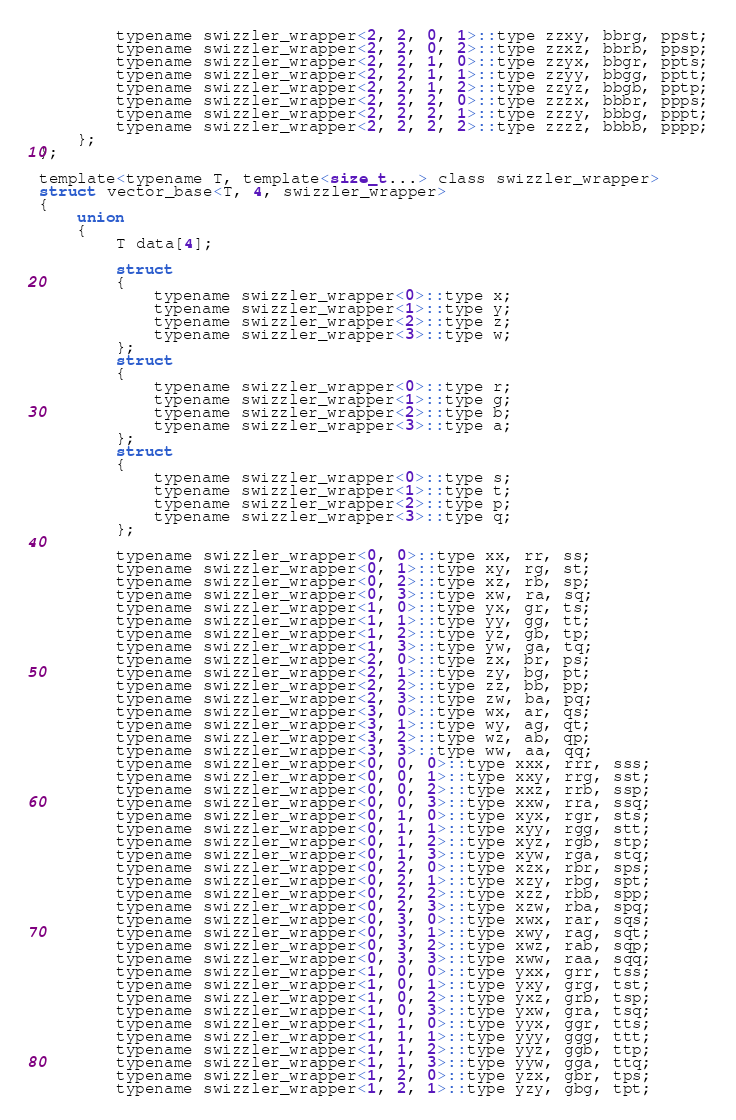Convert code to text. <code><loc_0><loc_0><loc_500><loc_500><_C_>		typename swizzler_wrapper<2, 2, 0, 1>::type zzxy, bbrg, ppst;
		typename swizzler_wrapper<2, 2, 0, 2>::type zzxz, bbrb, ppsp;
		typename swizzler_wrapper<2, 2, 1, 0>::type zzyx, bbgr, ppts;
		typename swizzler_wrapper<2, 2, 1, 1>::type zzyy, bbgg, pptt;
		typename swizzler_wrapper<2, 2, 1, 2>::type zzyz, bbgb, pptp;
		typename swizzler_wrapper<2, 2, 2, 0>::type zzzx, bbbr, ppps;
		typename swizzler_wrapper<2, 2, 2, 1>::type zzzy, bbbg, pppt;
		typename swizzler_wrapper<2, 2, 2, 2>::type zzzz, bbbb, pppp;
	};
};

template<typename T, template<size_t...> class swizzler_wrapper>
struct vector_base<T, 4, swizzler_wrapper>
{
	union
	{
		T data[4];

		struct
		{
			typename swizzler_wrapper<0>::type x;
			typename swizzler_wrapper<1>::type y;
			typename swizzler_wrapper<2>::type z;
			typename swizzler_wrapper<3>::type w;
		};
		struct
		{
			typename swizzler_wrapper<0>::type r;
			typename swizzler_wrapper<1>::type g;
			typename swizzler_wrapper<2>::type b;
			typename swizzler_wrapper<3>::type a;
		};
		struct
		{
			typename swizzler_wrapper<0>::type s;
			typename swizzler_wrapper<1>::type t;
			typename swizzler_wrapper<2>::type p;
			typename swizzler_wrapper<3>::type q;
		};

		typename swizzler_wrapper<0, 0>::type xx, rr, ss;
		typename swizzler_wrapper<0, 1>::type xy, rg, st;
		typename swizzler_wrapper<0, 2>::type xz, rb, sp;
		typename swizzler_wrapper<0, 3>::type xw, ra, sq;
		typename swizzler_wrapper<1, 0>::type yx, gr, ts;
		typename swizzler_wrapper<1, 1>::type yy, gg, tt;
		typename swizzler_wrapper<1, 2>::type yz, gb, tp;
		typename swizzler_wrapper<1, 3>::type yw, ga, tq;
		typename swizzler_wrapper<2, 0>::type zx, br, ps;
		typename swizzler_wrapper<2, 1>::type zy, bg, pt;
		typename swizzler_wrapper<2, 2>::type zz, bb, pp;
		typename swizzler_wrapper<2, 3>::type zw, ba, pq;
		typename swizzler_wrapper<3, 0>::type wx, ar, qs;
		typename swizzler_wrapper<3, 1>::type wy, ag, qt;
		typename swizzler_wrapper<3, 2>::type wz, ab, qp;
		typename swizzler_wrapper<3, 3>::type ww, aa, qq;
		typename swizzler_wrapper<0, 0, 0>::type xxx, rrr, sss;
		typename swizzler_wrapper<0, 0, 1>::type xxy, rrg, sst;
		typename swizzler_wrapper<0, 0, 2>::type xxz, rrb, ssp;
		typename swizzler_wrapper<0, 0, 3>::type xxw, rra, ssq;
		typename swizzler_wrapper<0, 1, 0>::type xyx, rgr, sts;
		typename swizzler_wrapper<0, 1, 1>::type xyy, rgg, stt;
		typename swizzler_wrapper<0, 1, 2>::type xyz, rgb, stp;
		typename swizzler_wrapper<0, 1, 3>::type xyw, rga, stq;
		typename swizzler_wrapper<0, 2, 0>::type xzx, rbr, sps;
		typename swizzler_wrapper<0, 2, 1>::type xzy, rbg, spt;
		typename swizzler_wrapper<0, 2, 2>::type xzz, rbb, spp;
		typename swizzler_wrapper<0, 2, 3>::type xzw, rba, spq;
		typename swizzler_wrapper<0, 3, 0>::type xwx, rar, sqs;
		typename swizzler_wrapper<0, 3, 1>::type xwy, rag, sqt;
		typename swizzler_wrapper<0, 3, 2>::type xwz, rab, sqp;
		typename swizzler_wrapper<0, 3, 3>::type xww, raa, sqq;
		typename swizzler_wrapper<1, 0, 0>::type yxx, grr, tss;
		typename swizzler_wrapper<1, 0, 1>::type yxy, grg, tst;
		typename swizzler_wrapper<1, 0, 2>::type yxz, grb, tsp;
		typename swizzler_wrapper<1, 0, 3>::type yxw, gra, tsq;
		typename swizzler_wrapper<1, 1, 0>::type yyx, ggr, tts;
		typename swizzler_wrapper<1, 1, 1>::type yyy, ggg, ttt;
		typename swizzler_wrapper<1, 1, 2>::type yyz, ggb, ttp;
		typename swizzler_wrapper<1, 1, 3>::type yyw, gga, ttq;
		typename swizzler_wrapper<1, 2, 0>::type yzx, gbr, tps;
		typename swizzler_wrapper<1, 2, 1>::type yzy, gbg, tpt;</code> 